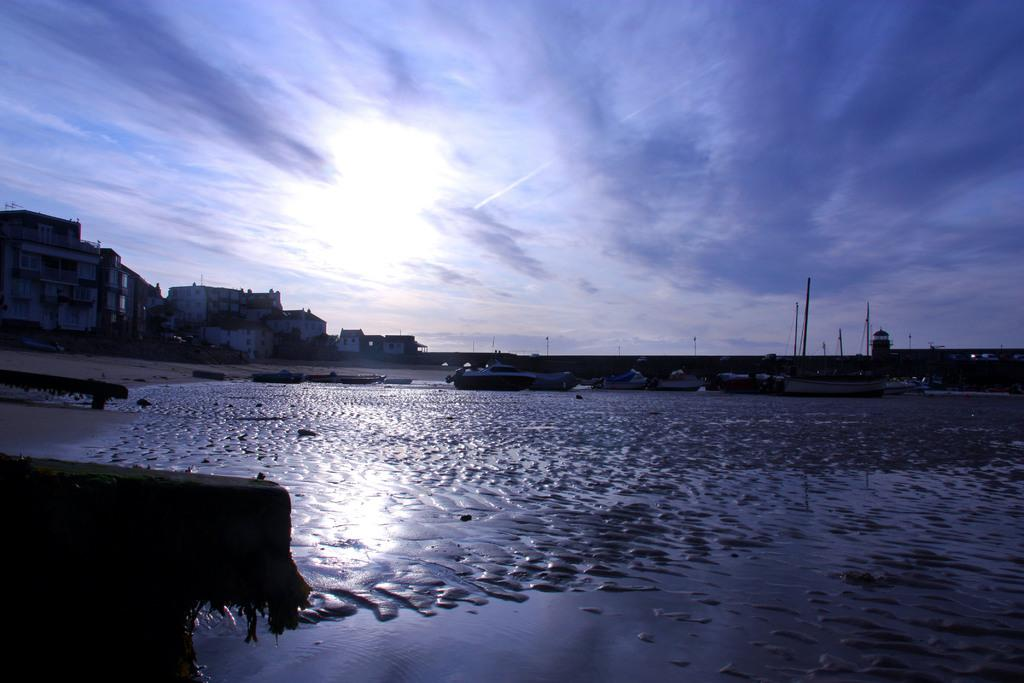What is the texture or material of the foreground in the image? The foreground of the image appears to be mud. What can be seen on the left side of the image? There is an object on the left side of the image. What is visible in the background of the image? There are boats, buildings, poles, and the sky visible in the background of the image. Can you describe the sky in the image? The sky is visible in the background of the image, and there is a cloud present. What type of harmony is being played by the swing in the image? There is no swing or harmony present in the image. How many screws are visible on the object in the image? There is no mention of screws or the object's specific details in the provided facts, so it cannot be determined from the image. 